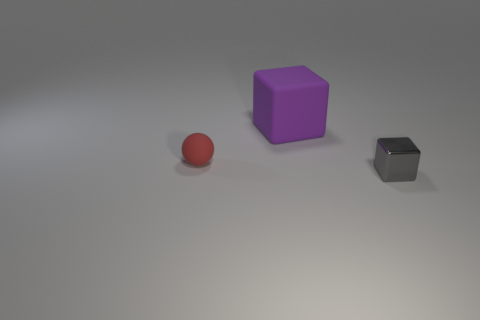Is the material of the small red ball the same as the cube that is in front of the large cube?
Give a very brief answer. No. Is there any other thing that has the same shape as the tiny gray metallic thing?
Offer a very short reply. Yes. What color is the object that is both right of the tiny red ball and behind the tiny gray object?
Your answer should be compact. Purple. What shape is the object that is on the left side of the big rubber cube?
Your answer should be very brief. Sphere. What is the size of the shiny cube that is on the right side of the matte object to the left of the cube left of the gray metallic block?
Your response must be concise. Small. There is a small thing in front of the tiny red rubber object; how many large purple things are on the right side of it?
Give a very brief answer. 0. There is a object that is both in front of the purple block and on the left side of the gray cube; how big is it?
Provide a succinct answer. Small. What number of shiny things are small red balls or purple cylinders?
Offer a terse response. 0. What is the tiny gray block made of?
Offer a very short reply. Metal. The cube that is in front of the tiny thing behind the object that is in front of the red thing is made of what material?
Your answer should be compact. Metal. 